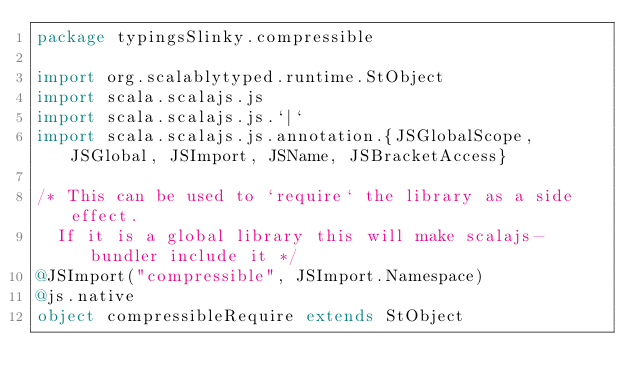<code> <loc_0><loc_0><loc_500><loc_500><_Scala_>package typingsSlinky.compressible

import org.scalablytyped.runtime.StObject
import scala.scalajs.js
import scala.scalajs.js.`|`
import scala.scalajs.js.annotation.{JSGlobalScope, JSGlobal, JSImport, JSName, JSBracketAccess}

/* This can be used to `require` the library as a side effect.
  If it is a global library this will make scalajs-bundler include it */
@JSImport("compressible", JSImport.Namespace)
@js.native
object compressibleRequire extends StObject
</code> 